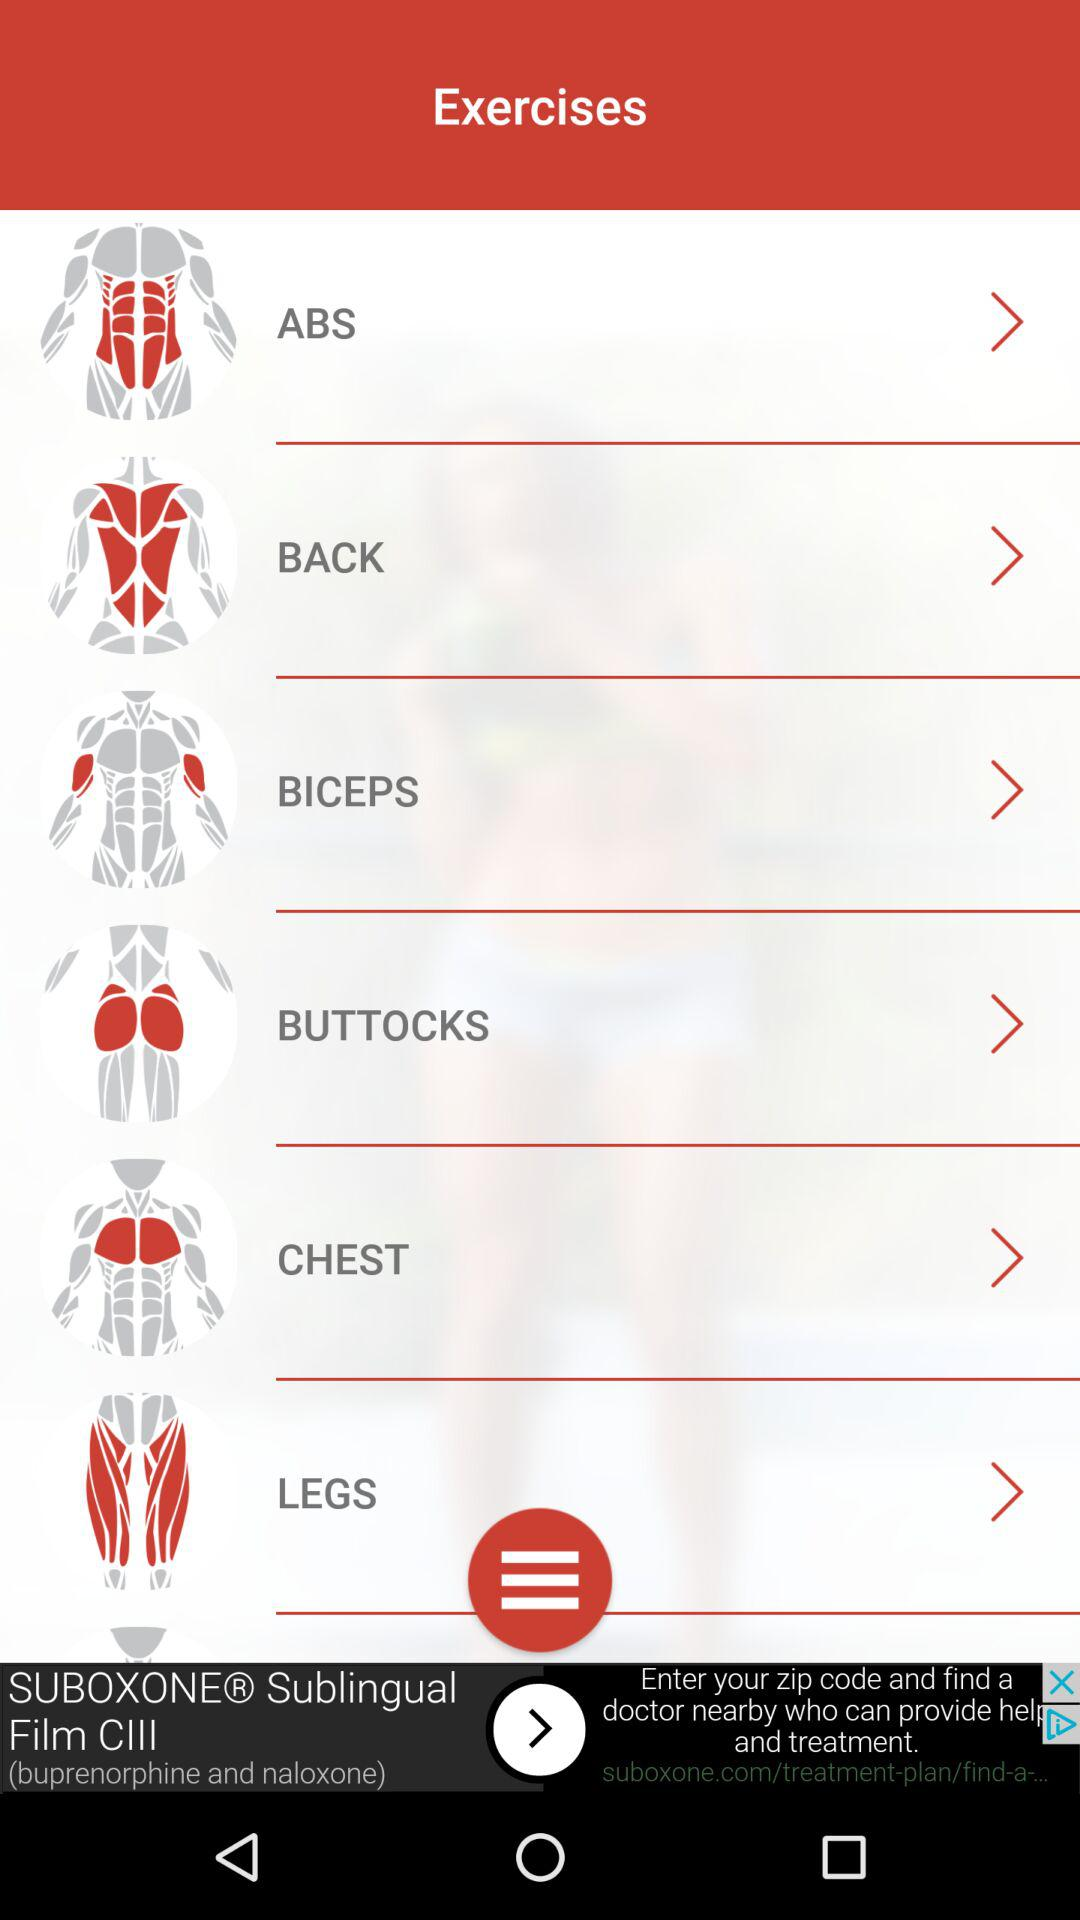What are the selected exercises?
When the provided information is insufficient, respond with <no answer>. <no answer> 